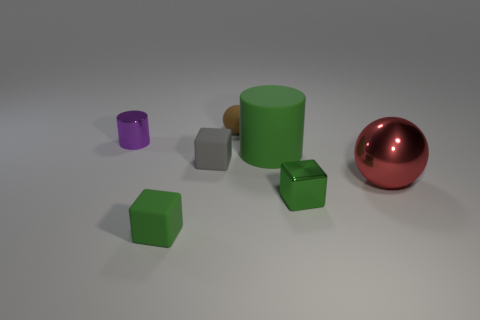There is a big object that is the same color as the shiny cube; what is its material?
Provide a succinct answer. Rubber. What is the size of the matte thing behind the tiny metal object that is on the left side of the tiny brown sphere?
Your answer should be very brief. Small. There is a large thing in front of the large cylinder; is its shape the same as the gray object?
Offer a terse response. No. What is the material of the other big thing that is the same shape as the purple object?
Keep it short and to the point. Rubber. How many objects are either large things in front of the gray object or tiny cubes that are on the right side of the tiny green matte block?
Ensure brevity in your answer.  3. Does the small rubber ball have the same color as the tiny metallic object that is right of the matte cylinder?
Provide a short and direct response. No. There is a green thing that is the same material as the large red sphere; what is its shape?
Provide a succinct answer. Cube. What number of red metallic spheres are there?
Give a very brief answer. 1. How many things are green things behind the big metal thing or matte objects?
Offer a terse response. 4. There is a small object right of the big green rubber cylinder; is its color the same as the big matte thing?
Provide a short and direct response. Yes. 